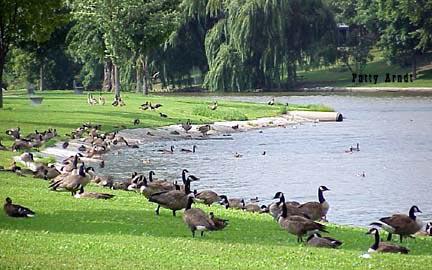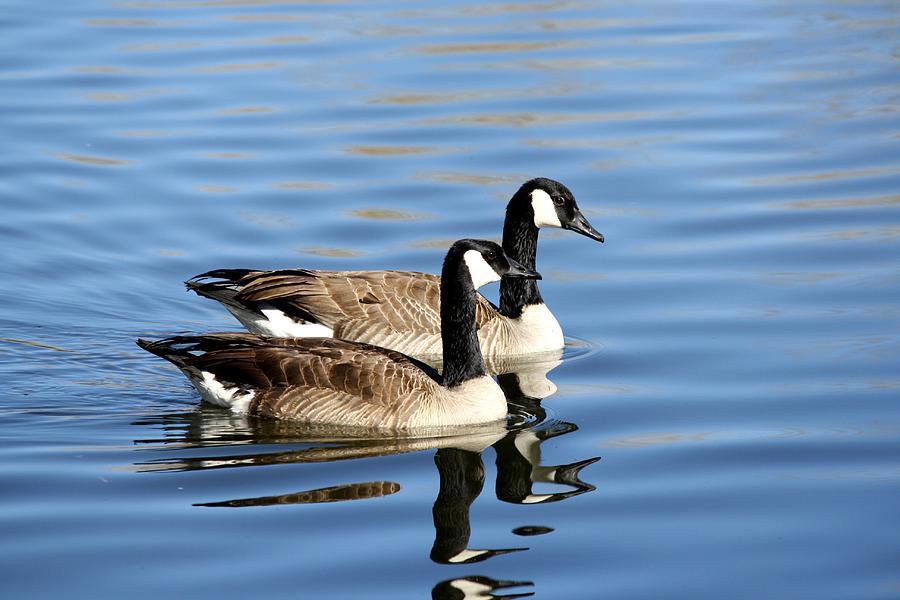The first image is the image on the left, the second image is the image on the right. Evaluate the accuracy of this statement regarding the images: "In the right image, there are two Canadian geese.". Is it true? Answer yes or no. Yes. The first image is the image on the left, the second image is the image on the right. Analyze the images presented: Is the assertion "the image on the right has 2 geese" valid? Answer yes or no. Yes. 